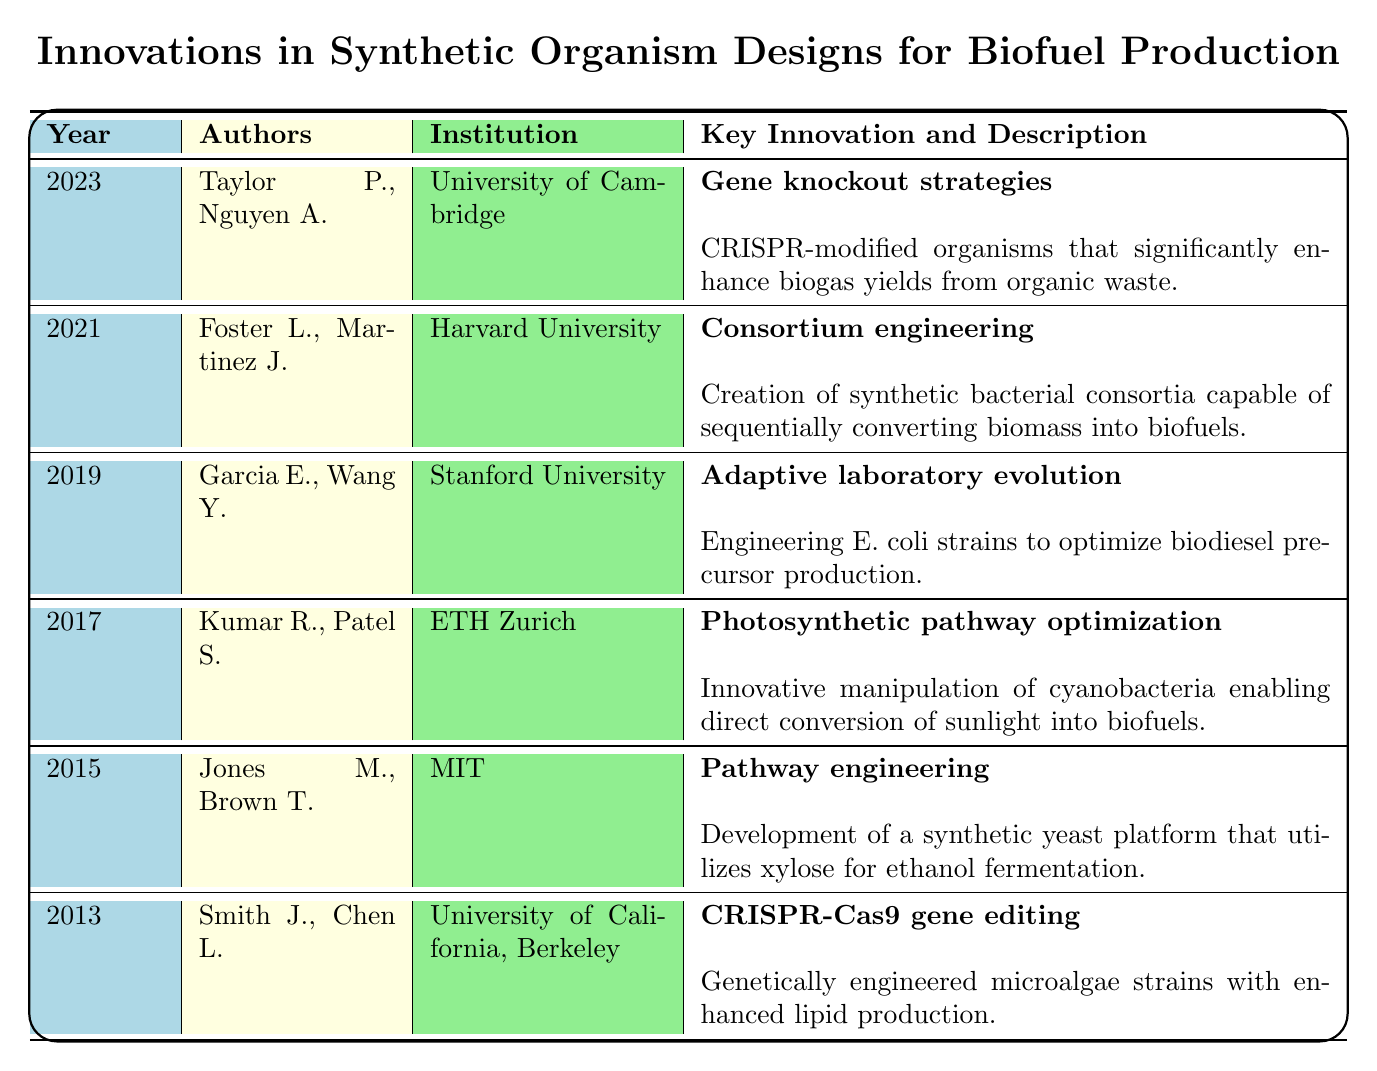What is the title of the research article published in 2023? The table indicates that the title for the research article from 2023 is "CRISPR-Engineered Organisms for Improved Biogas Production".
Answer: CRISPR-Engineered Organisms for Improved Biogas Production Who are the authors of the study conducted in 2015? From the table, the authors listed for the 2015 research article are Jones M. and Brown T.
Answer: Jones M., Brown T Which institution published the work on metabolic engineering in 2019? The entry for the year 2019 shows that the institution is Stanford University for the research on metabolic engineering.
Answer: Stanford University Is there a study that utilizes CRISPR technology for biofuel production? Yes, the study titled "Engineering Microalgae for Improved Biofuel Production" from 2013 used CRISPR-Cas9 gene editing.
Answer: Yes How many different institutions are represented in the table? By reviewing each entry, the institutions present are University of California, Berkeley; MIT; ETH Zurich; Stanford University; Harvard University; and University of Cambridge, totaling 6 distinct institutions.
Answer: 6 What key innovation was introduced in the 2021 study? The key innovation indicated for 2021 is "Consortium engineering" as per the description in the table.
Answer: Consortium engineering What is the year when the study about synthetic yeast was published, and what is the key innovation mentioned? The study about synthetic yeast was published in 2015, with the key innovation being "Pathway engineering".
Answer: 2015, Pathway engineering Which year saw the introduction of "Adaptive laboratory evolution"? The table mentions that "Adaptive laboratory evolution" was introduced with the study published in 2019.
Answer: 2019 What is the description of the study published in 2017? The description for the 2017 study is that it discusses the innovative manipulation of cyanobacteria enabling direct conversion of sunlight into biofuels.
Answer: Innovative manipulation of cyanobacteria enabling direct conversion of sunlight into biofuels 